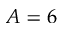Convert formula to latex. <formula><loc_0><loc_0><loc_500><loc_500>A = 6</formula> 